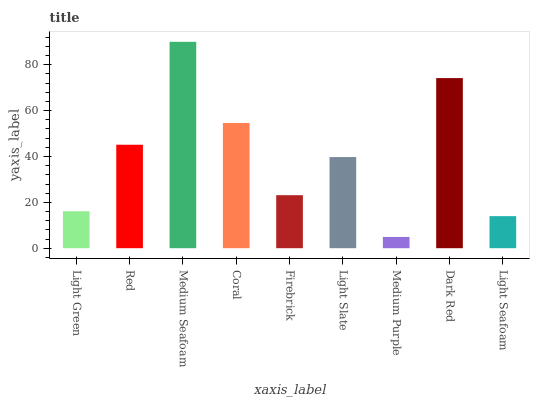Is Red the minimum?
Answer yes or no. No. Is Red the maximum?
Answer yes or no. No. Is Red greater than Light Green?
Answer yes or no. Yes. Is Light Green less than Red?
Answer yes or no. Yes. Is Light Green greater than Red?
Answer yes or no. No. Is Red less than Light Green?
Answer yes or no. No. Is Light Slate the high median?
Answer yes or no. Yes. Is Light Slate the low median?
Answer yes or no. Yes. Is Firebrick the high median?
Answer yes or no. No. Is Light Green the low median?
Answer yes or no. No. 